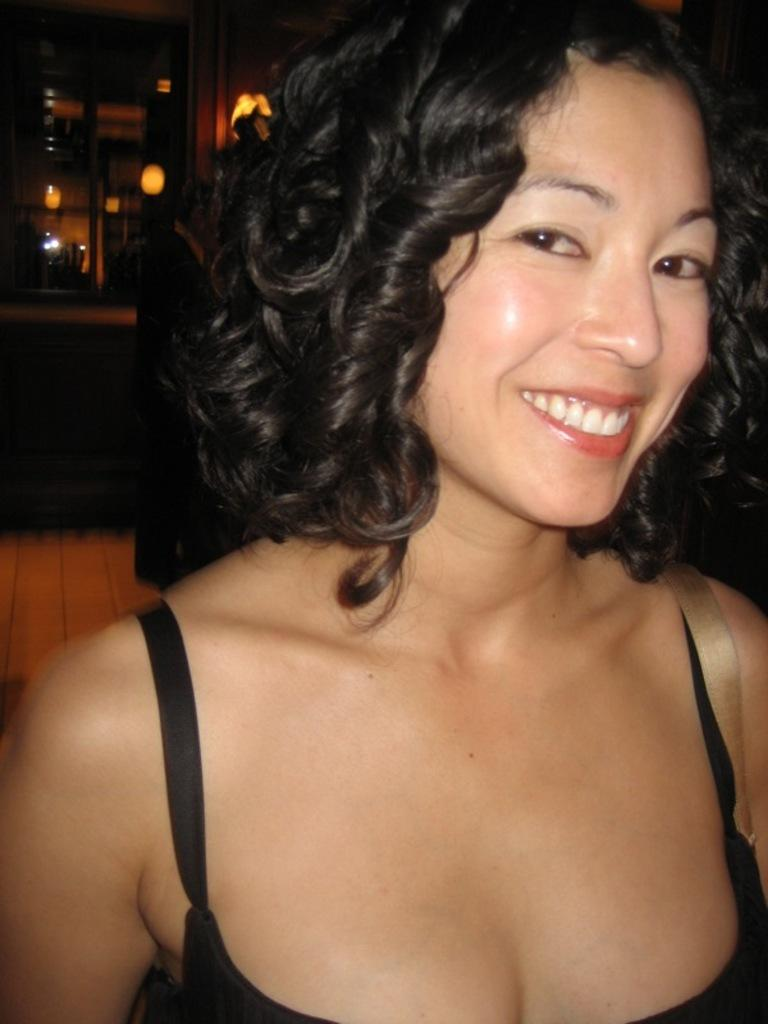Who is present in the image? There is a woman in the image. What is the woman wearing? The woman is wearing black clothes. What is the woman's facial expression? The woman is smiling. What can be seen in the background of the image? There are lights and other objects visible in the background of the image. What type of kite is the girl holding in the image? There is no girl or kite present in the image; it features a woman wearing black clothes and smiling. Is the woman reading a book in the image? There is no book or indication of reading in the image; the woman is simply smiling. 